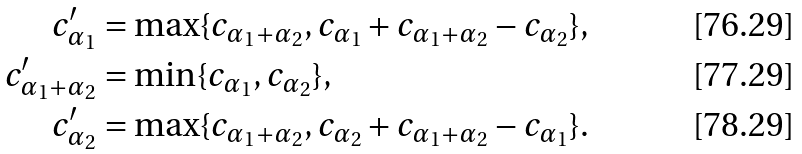Convert formula to latex. <formula><loc_0><loc_0><loc_500><loc_500>c ^ { \prime } _ { \alpha _ { 1 } } & = \max \{ c _ { \alpha _ { 1 } + \alpha _ { 2 } } , c _ { \alpha _ { 1 } } + c _ { \alpha _ { 1 } + \alpha _ { 2 } } - c _ { \alpha _ { 2 } } \} , \\ c ^ { \prime } _ { \alpha _ { 1 } + \alpha _ { 2 } } & = \min \{ c _ { \alpha _ { 1 } } , c _ { \alpha _ { 2 } } \} , \\ c ^ { \prime } _ { \alpha _ { 2 } } & = \max \{ c _ { \alpha _ { 1 } + \alpha _ { 2 } } , c _ { \alpha _ { 2 } } + c _ { \alpha _ { 1 } + \alpha _ { 2 } } - c _ { \alpha _ { 1 } } \} .</formula> 